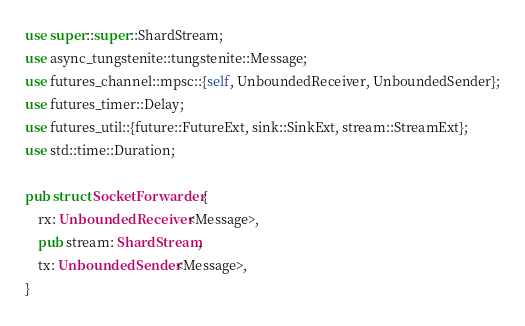Convert code to text. <code><loc_0><loc_0><loc_500><loc_500><_Rust_>use super::super::ShardStream;
use async_tungstenite::tungstenite::Message;
use futures_channel::mpsc::{self, UnboundedReceiver, UnboundedSender};
use futures_timer::Delay;
use futures_util::{future::FutureExt, sink::SinkExt, stream::StreamExt};
use std::time::Duration;

pub struct SocketForwarder {
    rx: UnboundedReceiver<Message>,
    pub stream: ShardStream,
    tx: UnboundedSender<Message>,
}
</code> 